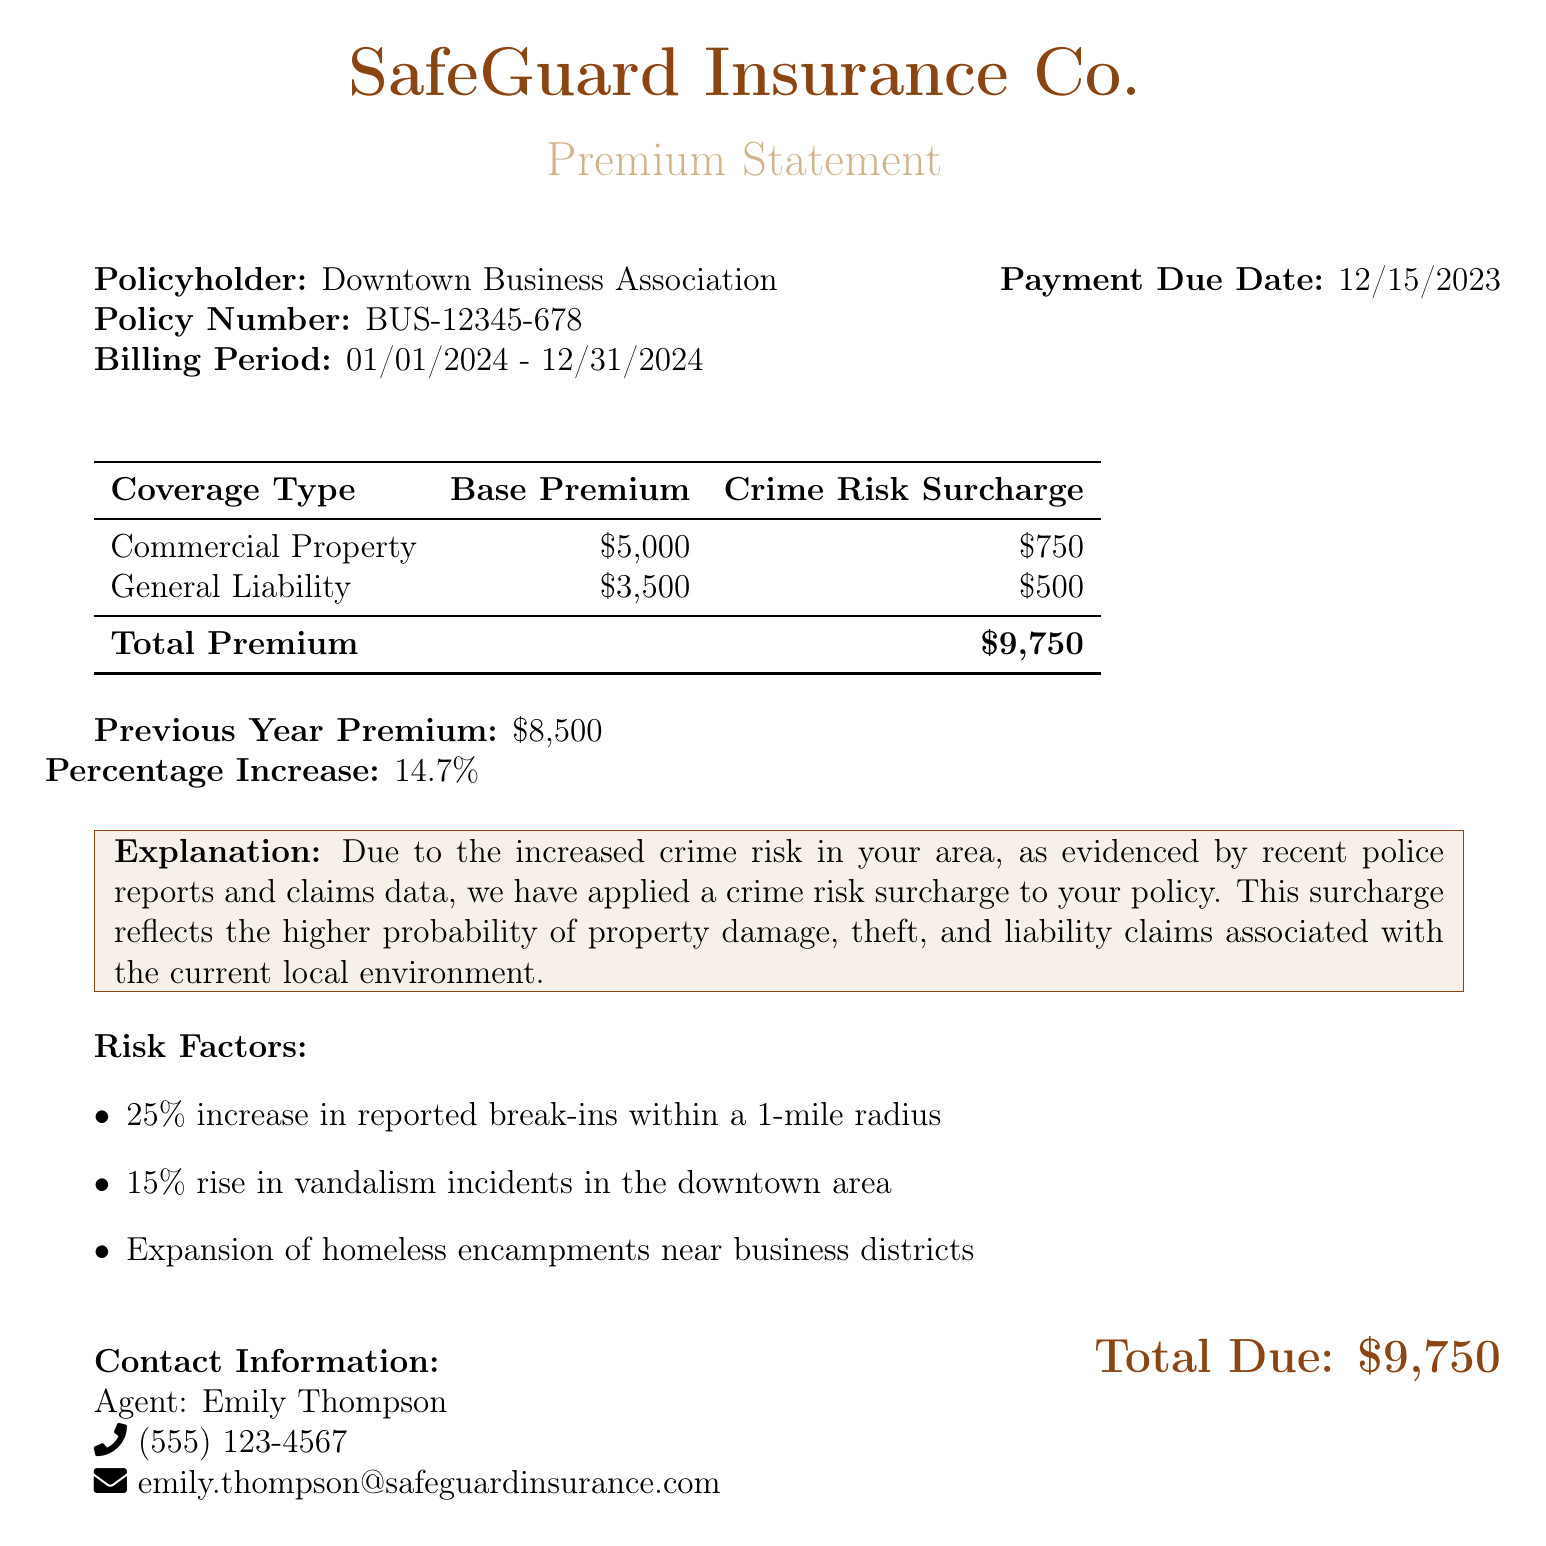What is the policyholder's name? The policyholder’s name is located at the top of the document under "Policyholder."
Answer: Downtown Business Association What is the billing period for this premium statement? The billing period is specified in the document and indicates the duration for which the premium is applicable.
Answer: 01/01/2024 - 12/31/2024 What is the total due amount? The total due amount is prominently displayed at the bottom of the document, summarizing the entire premium for the year.
Answer: $9,750 What is the percentage increase from the previous year’s premium? The percentage increase is calculated based on the previous year’s premium and the current year's total, provided in the document.
Answer: 14.7% What is the crime risk surcharge for General Liability coverage? The document quotes the specific surcharge applied to the General Liability coverage type.
Answer: $500 What are the three risk factors mentioned in the document? The risk factors are listed in an itemized format, summing up the various concerns leading to the increased premium.
Answer: 25% increase in reported break-ins, 15% rise in vandalism incidents, Expansion of homeless encampments Who is the insurance agent listed in the document? The agent's information is provided at the bottom of the statement, indicating who to contact for inquiries.
Answer: Emily Thompson When is the payment due date? The payment due date is clearly stated in a separate section of the document.
Answer: 12/15/2023 